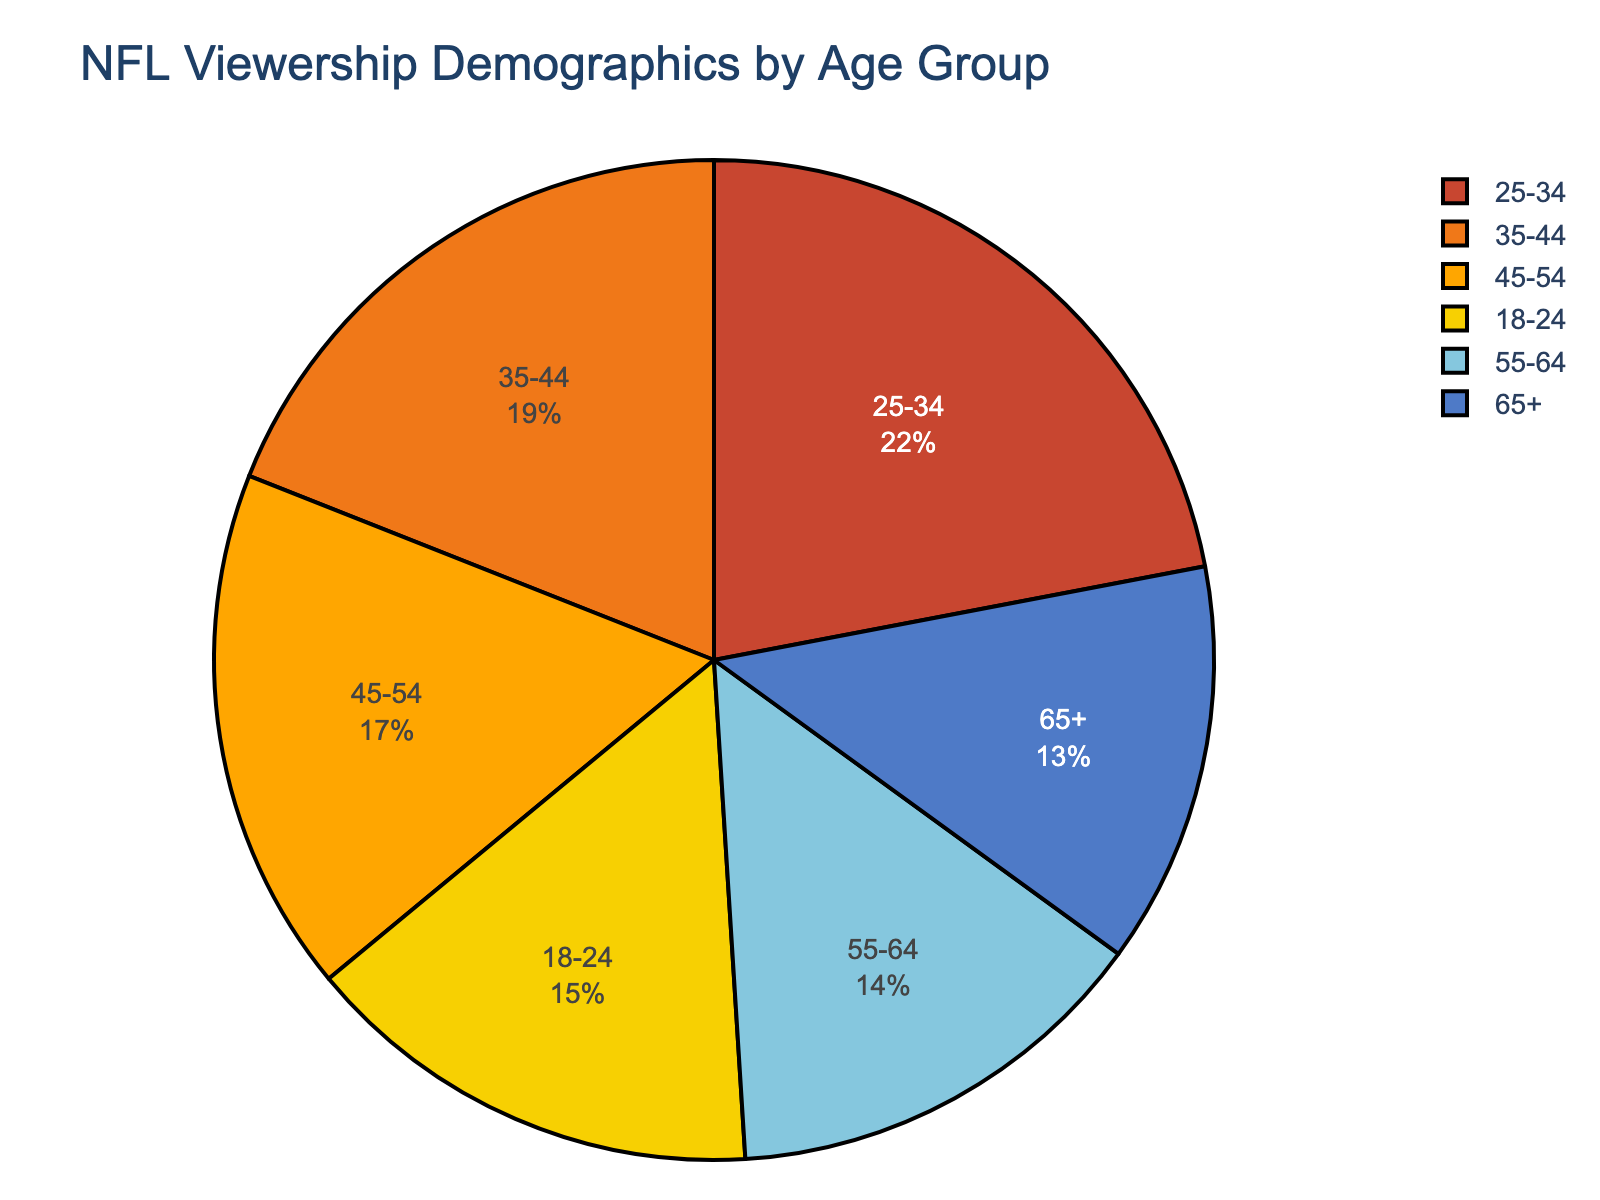What age group has the highest percentage of NFL viewership? By looking at the figure, we identify the age group with the largest slice. The colors and labels indicate that the 25-34 age group has the highest percentage.
Answer: 25-34 Which age group has the lowest percentage of NFL viewership? Observing the pie chart, the smallest slice corresponds to the 65+ age group.
Answer: 65+ What is the combined percentage of NFL viewership for the age groups 18-24 and 65+? The 18-24 age group has 15% and the 65+ age group has 13%. Adding these percentages gives us 15 + 13 = 28%.
Answer: 28% How much more popular is the 25-34 age group compared to the 55-64 age group? The 25-34 age group has 22%, and the 55-64 age group has 14%. The difference is 22 - 14 = 8%.
Answer: 8% Which two age groups have a combined viewership percentage closest to 50%? To determine this, we sum the percentages of different pairs. Summing the 25-34 (22%) and 35-44 (19%) results in 41%; summing 25-34 (22%) and 45-54 (17%) results in 39%; summing 25-34 (22%) and 18-24 (15%) results in 37%. The closest pair is 25-34 and 35-44, with a combined total of 41%.
Answer: 25-34 and 35-44 What is the total percentage of NFL viewership from age groups below 35? Adding the percentages for age groups 18-24 (15%) and 25-34 (22%) gives us 15 + 22 = 37%.
Answer: 37% If the percentage needs to be split equally among three age groups, which combination comes closest to the target percentage of 33.33% each? Summing the percentages: (22 + 14 + 13) = 49%, (19 + 15 + 17) = 51%. The combination closest to this target is 25-34, 55-64, and 65+ with a total percentage of 22 + 14 + 13 = 49%.
Answer: 25-34, 55-64, and 65+ Which two adjacent age groups, when combined, have the greatest percentage of NFL viewership? The adjacent age groups 25-34 (22%) and 35-44 (19%) sum up to 41%, which is the largest combination among all adjacent pairs.
Answer: 25-34 and 35-44 What is the difference in viewership percentage between the age groups 35-44 and 45-54? The 35-44 age group has 19%, and the 45-54 age group has 17%. The difference is 19 - 17 = 2%.
Answer: 2% What is the average percentage of NFL viewership among the age groups 45-54, 55-64, and 65+? Adding the percentages for these age groups: 17% (45-54), 14% (55-64), and 13% (65+), we get 17 + 14 + 13 = 44. Dividing by 3 gives us an average of 44 / 3 ≈ 14.67%.
Answer: Approximately 14.67% 